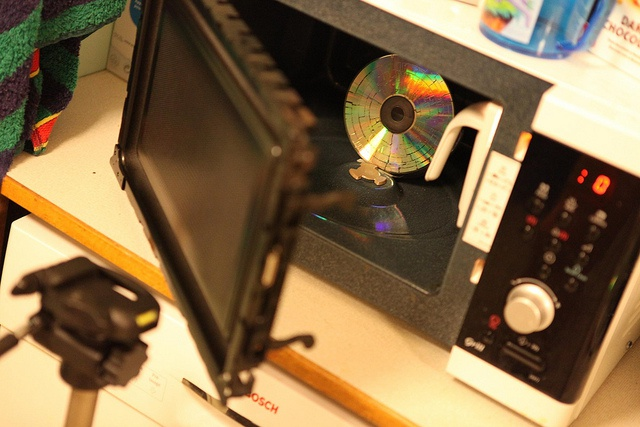Describe the objects in this image and their specific colors. I can see a microwave in black, maroon, and lightyellow tones in this image. 